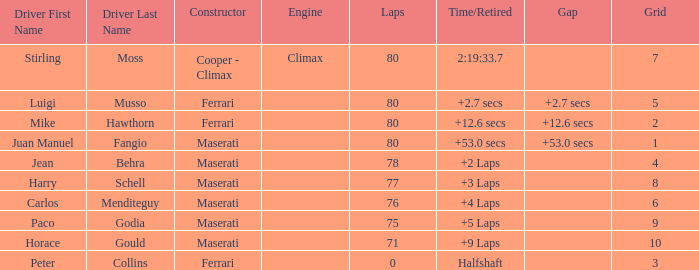Who was driving the Maserati with a Grid smaller than 6, and a Time/Retired of +2 laps? Jean Behra. 